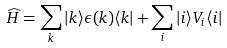<formula> <loc_0><loc_0><loc_500><loc_500>\widehat { H } = \sum _ { k } | k \rangle \epsilon ( k ) \langle k | + \sum _ { i } | i \rangle V _ { i } \langle i |</formula> 